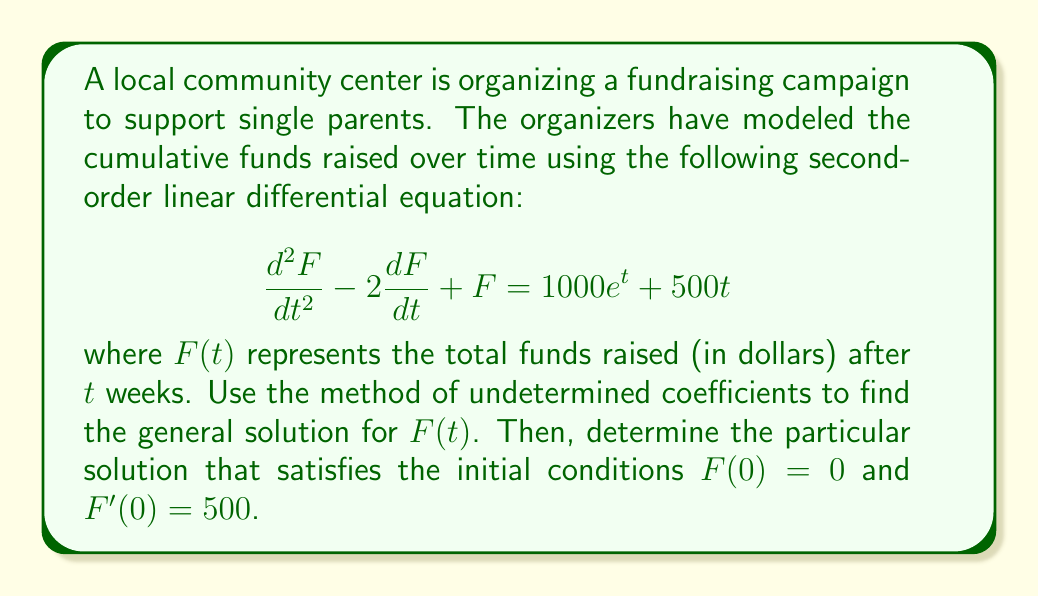What is the answer to this math problem? Let's solve this step-by-step using the method of undetermined coefficients:

1) The homogeneous equation is:
   $$\frac{d^2F}{dt^2} - 2\frac{dF}{dt} + F = 0$$

   The characteristic equation is:
   $$r^2 - 2r + 1 = 0$$
   $$(r - 1)^2 = 0$$

   So, $r = 1$ (repeated root). The homogeneous solution is:
   $$F_h(t) = c_1e^t + c_2te^t$$

2) For the particular solution, we need to consider both $1000e^t$ and $500t$:

   For $1000e^t$, try $F_{p1}(t) = Ae^t$
   For $500t$, try $F_{p2}(t) = Bt + C$

   So, $F_p(t) = Ae^t + Bt + C$

3) Substitute $F_p(t)$ into the original equation:
   $$(Ae^t + B) - 2(Ae^t + B) + (Ae^t + Bt + C) = 1000e^t + 500t$$

   Simplify:
   $$Bt + C = 1000e^t + 500t$$

4) Equating coefficients:
   $e^t: 0 = 1000$, so $A = 1000$
   $t: B = 500$
   constant: $C = 0$

5) The particular solution is:
   $$F_p(t) = 1000e^t + 500t$$

6) The general solution is:
   $$F(t) = F_h(t) + F_p(t) = c_1e^t + c_2te^t + 1000e^t + 500t$$

7) To find $c_1$ and $c_2$, use the initial conditions:

   $F(0) = 0$:
   $$c_1 + 1000 = 0$$
   $$c_1 = -1000$$

   $F'(0) = 500$:
   $$c_1 + c_2 + 1000 + 500 = 500$$
   $$-1000 + c_2 + 1000 + 500 = 500$$
   $$c_2 = 0$$

8) The particular solution that satisfies the initial conditions is:
   $$F(t) = -1000e^t + 1000e^t + 500t = 500t$$
Answer: $F(t) = 500t$ 